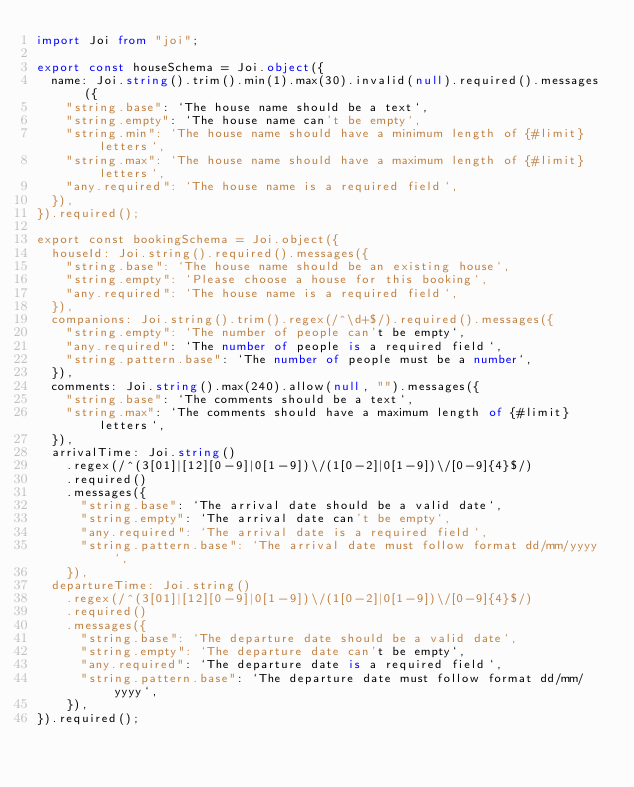<code> <loc_0><loc_0><loc_500><loc_500><_TypeScript_>import Joi from "joi";

export const houseSchema = Joi.object({
  name: Joi.string().trim().min(1).max(30).invalid(null).required().messages({
    "string.base": `The house name should be a text`,
    "string.empty": `The house name can't be empty`,
    "string.min": `The house name should have a minimum length of {#limit} letters`,
    "string.max": `The house name should have a maximum length of {#limit} letters`,
    "any.required": `The house name is a required field`,
  }),
}).required();

export const bookingSchema = Joi.object({
  houseId: Joi.string().required().messages({
    "string.base": `The house name should be an existing house`,
    "string.empty": `Please choose a house for this booking`,
    "any.required": `The house name is a required field`,
  }),
  companions: Joi.string().trim().regex(/^\d+$/).required().messages({
    "string.empty": `The number of people can't be empty`,
    "any.required": `The number of people is a required field`,
    "string.pattern.base": `The number of people must be a number`,
  }),
  comments: Joi.string().max(240).allow(null, "").messages({
    "string.base": `The comments should be a text`,
    "string.max": `The comments should have a maximum length of {#limit} letters`,
  }),
  arrivalTime: Joi.string()
    .regex(/^(3[01]|[12][0-9]|0[1-9])\/(1[0-2]|0[1-9])\/[0-9]{4}$/)
    .required()
    .messages({
      "string.base": `The arrival date should be a valid date`,
      "string.empty": `The arrival date can't be empty`,
      "any.required": `The arrival date is a required field`,
      "string.pattern.base": `The arrival date must follow format dd/mm/yyyy`,
    }),
  departureTime: Joi.string()
    .regex(/^(3[01]|[12][0-9]|0[1-9])\/(1[0-2]|0[1-9])\/[0-9]{4}$/)
    .required()
    .messages({
      "string.base": `The departure date should be a valid date`,
      "string.empty": `The departure date can't be empty`,
      "any.required": `The departure date is a required field`,
      "string.pattern.base": `The departure date must follow format dd/mm/yyyy`,
    }),
}).required();
</code> 